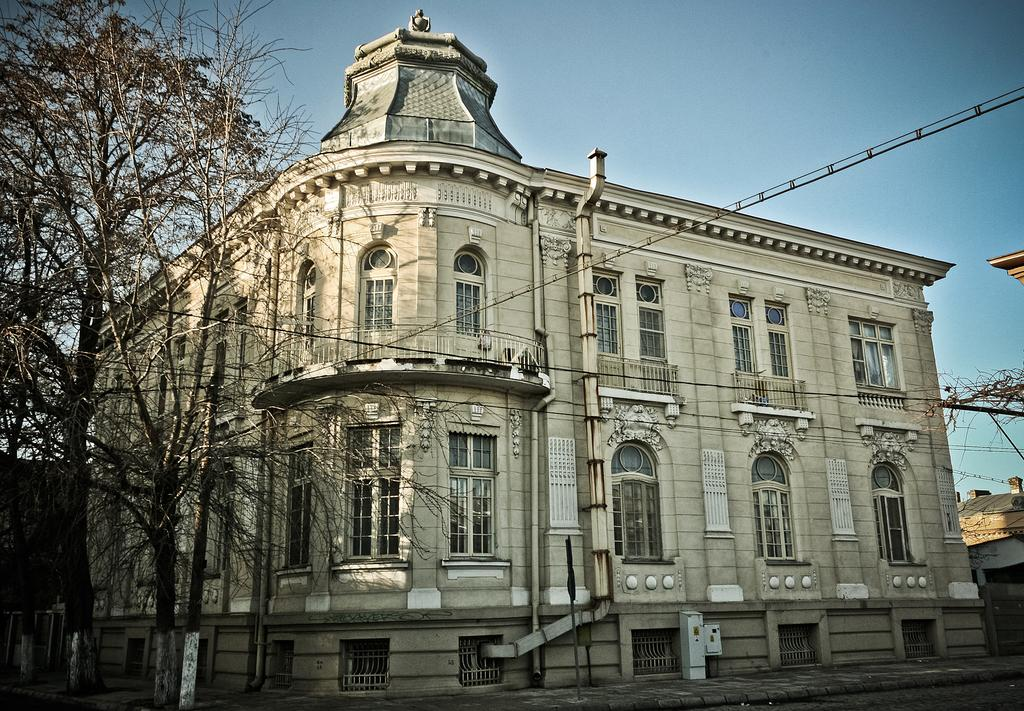What type of vegetation is on the left side of the image? There are trees on the left side of the image. What structure is located in the center of the image? There is a building in the center of the image. What is the surface material in the foreground of the image? The foreground of the image contains pavement. What type of vegetation is on the right side of the image? There is a tree on the right side of the image. How would you describe the weather in the image? The sky is sunny in the image. Can you tell me how many holes are present in the tree on the right side of the image? There is no mention of any holes in the tree on the right side of the image, so it is not possible to answer that question. What type of plot is being developed in the image? There is no indication of any plot development in the image; it primarily features trees, a building, pavement, and a sunny sky. 